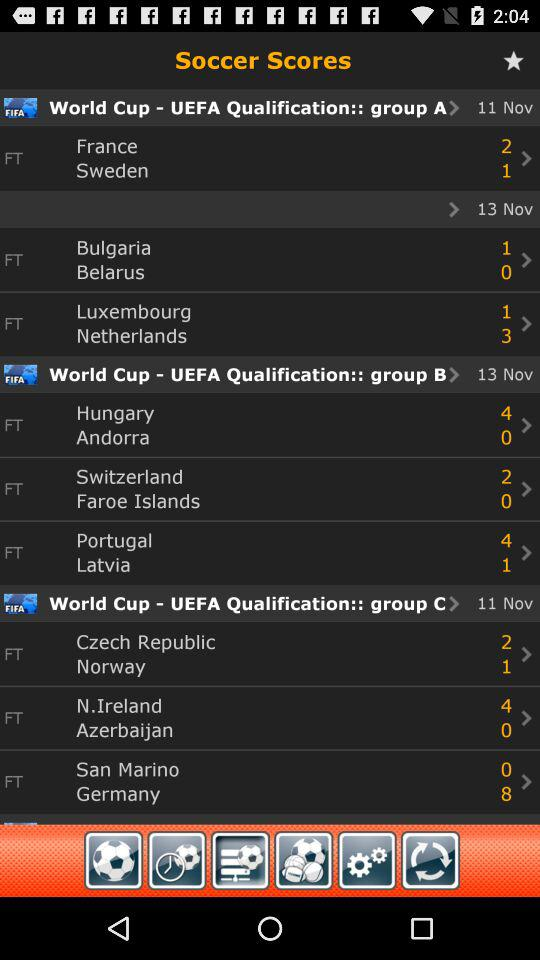Which countries are in Group A of the "World Cup - UEFA Qualification"? The countries that are in Group A of the "World Cup - UEFA Qualification" are France, Sweden, Bulgaria, Belarus, Luxembourg and the Netherlands. 